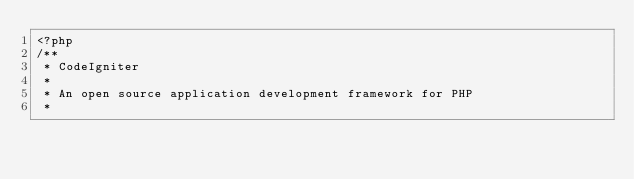<code> <loc_0><loc_0><loc_500><loc_500><_PHP_><?php
/**
 * CodeIgniter
 *
 * An open source application development framework for PHP
 *</code> 